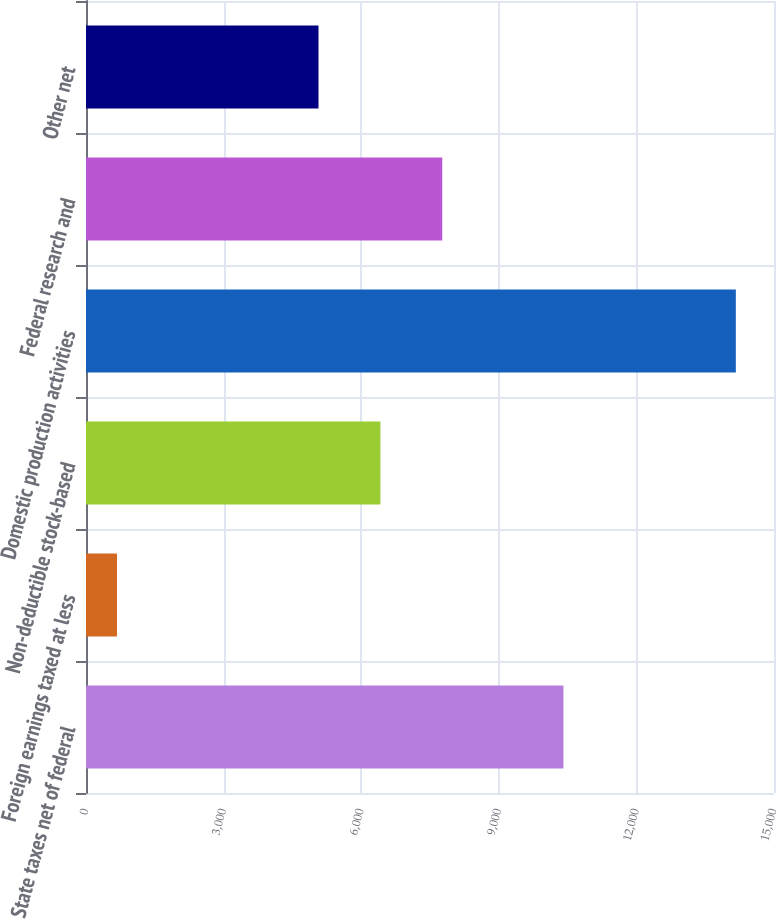<chart> <loc_0><loc_0><loc_500><loc_500><bar_chart><fcel>State taxes net of federal<fcel>Foreign earnings taxed at less<fcel>Non-deductible stock-based<fcel>Domestic production activities<fcel>Federal research and<fcel>Other net<nl><fcel>10409<fcel>676<fcel>6418.2<fcel>14168<fcel>7767.4<fcel>5069<nl></chart> 